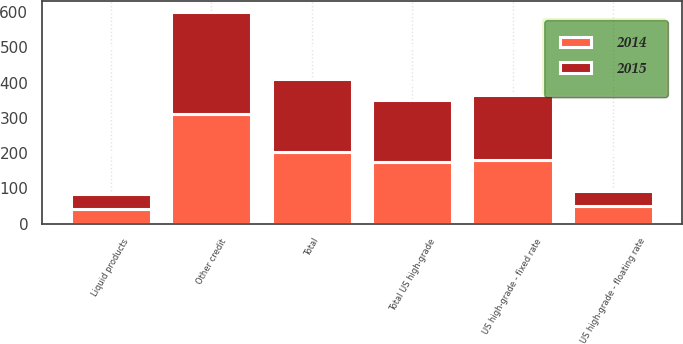<chart> <loc_0><loc_0><loc_500><loc_500><stacked_bar_chart><ecel><fcel>US high-grade - fixed rate<fcel>US high-grade - floating rate<fcel>Total US high-grade<fcel>Other credit<fcel>Liquid products<fcel>Total<nl><fcel>2015<fcel>182<fcel>42<fcel>175<fcel>290<fcel>40<fcel>206<nl><fcel>2014<fcel>182<fcel>51<fcel>175<fcel>311<fcel>43<fcel>204<nl></chart> 